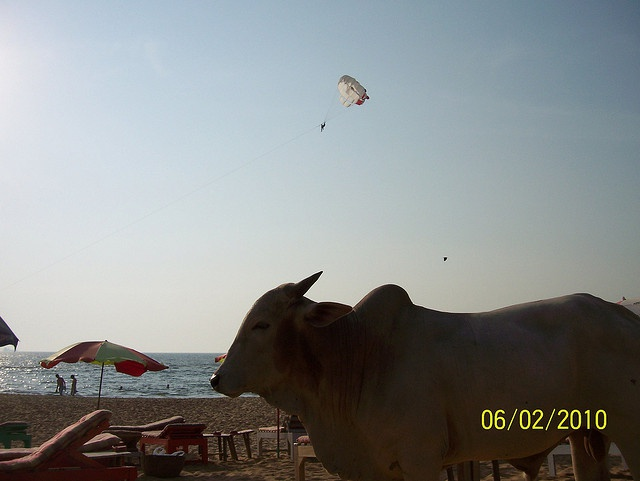Describe the objects in this image and their specific colors. I can see cow in lavender, black, yellow, and darkgreen tones, chair in lavender, black, maroon, and gray tones, umbrella in lavender, maroon, black, gray, and darkgreen tones, umbrella in lavender, black, and gray tones, and people in lavender, black, gray, darkgreen, and darkgray tones in this image. 